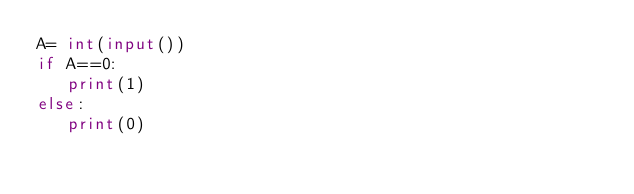<code> <loc_0><loc_0><loc_500><loc_500><_Python_>A= int(input())
if A==0:
   print(1)
else:
   print(0)</code> 